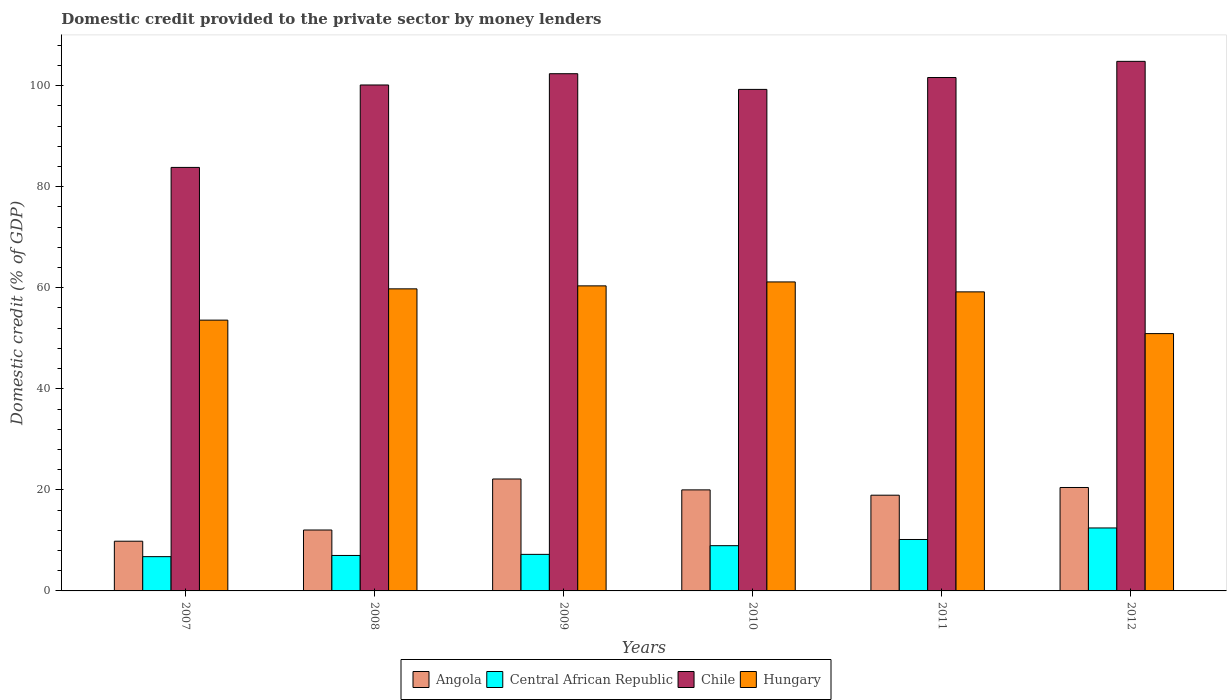How many different coloured bars are there?
Offer a very short reply. 4. How many bars are there on the 2nd tick from the right?
Provide a short and direct response. 4. What is the label of the 3rd group of bars from the left?
Your response must be concise. 2009. In how many cases, is the number of bars for a given year not equal to the number of legend labels?
Make the answer very short. 0. What is the domestic credit provided to the private sector by money lenders in Central African Republic in 2012?
Provide a short and direct response. 12.46. Across all years, what is the maximum domestic credit provided to the private sector by money lenders in Central African Republic?
Offer a terse response. 12.46. Across all years, what is the minimum domestic credit provided to the private sector by money lenders in Hungary?
Make the answer very short. 50.93. In which year was the domestic credit provided to the private sector by money lenders in Central African Republic maximum?
Offer a very short reply. 2012. In which year was the domestic credit provided to the private sector by money lenders in Central African Republic minimum?
Make the answer very short. 2007. What is the total domestic credit provided to the private sector by money lenders in Hungary in the graph?
Your answer should be compact. 345.05. What is the difference between the domestic credit provided to the private sector by money lenders in Central African Republic in 2008 and that in 2010?
Give a very brief answer. -1.94. What is the difference between the domestic credit provided to the private sector by money lenders in Central African Republic in 2008 and the domestic credit provided to the private sector by money lenders in Angola in 2011?
Keep it short and to the point. -11.93. What is the average domestic credit provided to the private sector by money lenders in Chile per year?
Provide a short and direct response. 98.67. In the year 2012, what is the difference between the domestic credit provided to the private sector by money lenders in Chile and domestic credit provided to the private sector by money lenders in Hungary?
Offer a terse response. 53.89. In how many years, is the domestic credit provided to the private sector by money lenders in Hungary greater than 80 %?
Provide a succinct answer. 0. What is the ratio of the domestic credit provided to the private sector by money lenders in Angola in 2010 to that in 2012?
Keep it short and to the point. 0.98. What is the difference between the highest and the second highest domestic credit provided to the private sector by money lenders in Hungary?
Provide a succinct answer. 0.78. What is the difference between the highest and the lowest domestic credit provided to the private sector by money lenders in Hungary?
Give a very brief answer. 10.23. Is the sum of the domestic credit provided to the private sector by money lenders in Hungary in 2009 and 2012 greater than the maximum domestic credit provided to the private sector by money lenders in Chile across all years?
Offer a very short reply. Yes. Is it the case that in every year, the sum of the domestic credit provided to the private sector by money lenders in Angola and domestic credit provided to the private sector by money lenders in Chile is greater than the sum of domestic credit provided to the private sector by money lenders in Hungary and domestic credit provided to the private sector by money lenders in Central African Republic?
Your answer should be very brief. No. What does the 1st bar from the right in 2012 represents?
Offer a very short reply. Hungary. Is it the case that in every year, the sum of the domestic credit provided to the private sector by money lenders in Angola and domestic credit provided to the private sector by money lenders in Hungary is greater than the domestic credit provided to the private sector by money lenders in Central African Republic?
Keep it short and to the point. Yes. What is the difference between two consecutive major ticks on the Y-axis?
Provide a succinct answer. 20. Does the graph contain grids?
Offer a very short reply. No. Where does the legend appear in the graph?
Offer a very short reply. Bottom center. How many legend labels are there?
Ensure brevity in your answer.  4. How are the legend labels stacked?
Keep it short and to the point. Horizontal. What is the title of the graph?
Make the answer very short. Domestic credit provided to the private sector by money lenders. What is the label or title of the Y-axis?
Make the answer very short. Domestic credit (% of GDP). What is the Domestic credit (% of GDP) in Angola in 2007?
Provide a succinct answer. 9.84. What is the Domestic credit (% of GDP) of Central African Republic in 2007?
Provide a succinct answer. 6.78. What is the Domestic credit (% of GDP) in Chile in 2007?
Keep it short and to the point. 83.82. What is the Domestic credit (% of GDP) of Hungary in 2007?
Your answer should be compact. 53.6. What is the Domestic credit (% of GDP) of Angola in 2008?
Your answer should be compact. 12.06. What is the Domestic credit (% of GDP) in Central African Republic in 2008?
Ensure brevity in your answer.  7.02. What is the Domestic credit (% of GDP) of Chile in 2008?
Offer a terse response. 100.14. What is the Domestic credit (% of GDP) in Hungary in 2008?
Your answer should be very brief. 59.79. What is the Domestic credit (% of GDP) in Angola in 2009?
Provide a short and direct response. 22.15. What is the Domestic credit (% of GDP) of Central African Republic in 2009?
Your answer should be very brief. 7.23. What is the Domestic credit (% of GDP) of Chile in 2009?
Offer a very short reply. 102.37. What is the Domestic credit (% of GDP) of Hungary in 2009?
Your answer should be compact. 60.38. What is the Domestic credit (% of GDP) of Angola in 2010?
Provide a short and direct response. 20. What is the Domestic credit (% of GDP) in Central African Republic in 2010?
Your answer should be compact. 8.96. What is the Domestic credit (% of GDP) of Chile in 2010?
Ensure brevity in your answer.  99.27. What is the Domestic credit (% of GDP) of Hungary in 2010?
Your answer should be compact. 61.16. What is the Domestic credit (% of GDP) in Angola in 2011?
Make the answer very short. 18.95. What is the Domestic credit (% of GDP) in Central African Republic in 2011?
Offer a very short reply. 10.18. What is the Domestic credit (% of GDP) in Chile in 2011?
Your answer should be compact. 101.62. What is the Domestic credit (% of GDP) in Hungary in 2011?
Keep it short and to the point. 59.19. What is the Domestic credit (% of GDP) in Angola in 2012?
Make the answer very short. 20.47. What is the Domestic credit (% of GDP) in Central African Republic in 2012?
Make the answer very short. 12.46. What is the Domestic credit (% of GDP) in Chile in 2012?
Ensure brevity in your answer.  104.82. What is the Domestic credit (% of GDP) of Hungary in 2012?
Keep it short and to the point. 50.93. Across all years, what is the maximum Domestic credit (% of GDP) of Angola?
Offer a terse response. 22.15. Across all years, what is the maximum Domestic credit (% of GDP) in Central African Republic?
Ensure brevity in your answer.  12.46. Across all years, what is the maximum Domestic credit (% of GDP) in Chile?
Keep it short and to the point. 104.82. Across all years, what is the maximum Domestic credit (% of GDP) of Hungary?
Ensure brevity in your answer.  61.16. Across all years, what is the minimum Domestic credit (% of GDP) of Angola?
Give a very brief answer. 9.84. Across all years, what is the minimum Domestic credit (% of GDP) in Central African Republic?
Offer a terse response. 6.78. Across all years, what is the minimum Domestic credit (% of GDP) of Chile?
Your answer should be very brief. 83.82. Across all years, what is the minimum Domestic credit (% of GDP) in Hungary?
Provide a succinct answer. 50.93. What is the total Domestic credit (% of GDP) in Angola in the graph?
Your answer should be very brief. 103.47. What is the total Domestic credit (% of GDP) of Central African Republic in the graph?
Offer a terse response. 52.64. What is the total Domestic credit (% of GDP) in Chile in the graph?
Offer a very short reply. 592.04. What is the total Domestic credit (% of GDP) in Hungary in the graph?
Ensure brevity in your answer.  345.05. What is the difference between the Domestic credit (% of GDP) in Angola in 2007 and that in 2008?
Keep it short and to the point. -2.22. What is the difference between the Domestic credit (% of GDP) in Central African Republic in 2007 and that in 2008?
Offer a very short reply. -0.24. What is the difference between the Domestic credit (% of GDP) in Chile in 2007 and that in 2008?
Your response must be concise. -16.32. What is the difference between the Domestic credit (% of GDP) of Hungary in 2007 and that in 2008?
Provide a succinct answer. -6.19. What is the difference between the Domestic credit (% of GDP) in Angola in 2007 and that in 2009?
Your answer should be very brief. -12.32. What is the difference between the Domestic credit (% of GDP) in Central African Republic in 2007 and that in 2009?
Give a very brief answer. -0.45. What is the difference between the Domestic credit (% of GDP) in Chile in 2007 and that in 2009?
Your answer should be compact. -18.55. What is the difference between the Domestic credit (% of GDP) of Hungary in 2007 and that in 2009?
Offer a very short reply. -6.78. What is the difference between the Domestic credit (% of GDP) in Angola in 2007 and that in 2010?
Your answer should be very brief. -10.16. What is the difference between the Domestic credit (% of GDP) in Central African Republic in 2007 and that in 2010?
Your response must be concise. -2.17. What is the difference between the Domestic credit (% of GDP) in Chile in 2007 and that in 2010?
Offer a very short reply. -15.44. What is the difference between the Domestic credit (% of GDP) of Hungary in 2007 and that in 2010?
Your response must be concise. -7.56. What is the difference between the Domestic credit (% of GDP) in Angola in 2007 and that in 2011?
Ensure brevity in your answer.  -9.11. What is the difference between the Domestic credit (% of GDP) of Central African Republic in 2007 and that in 2011?
Make the answer very short. -3.4. What is the difference between the Domestic credit (% of GDP) of Chile in 2007 and that in 2011?
Provide a short and direct response. -17.79. What is the difference between the Domestic credit (% of GDP) in Hungary in 2007 and that in 2011?
Your answer should be compact. -5.59. What is the difference between the Domestic credit (% of GDP) in Angola in 2007 and that in 2012?
Provide a succinct answer. -10.63. What is the difference between the Domestic credit (% of GDP) of Central African Republic in 2007 and that in 2012?
Your answer should be compact. -5.68. What is the difference between the Domestic credit (% of GDP) of Chile in 2007 and that in 2012?
Your response must be concise. -20.99. What is the difference between the Domestic credit (% of GDP) in Hungary in 2007 and that in 2012?
Provide a succinct answer. 2.67. What is the difference between the Domestic credit (% of GDP) of Angola in 2008 and that in 2009?
Your answer should be very brief. -10.1. What is the difference between the Domestic credit (% of GDP) of Central African Republic in 2008 and that in 2009?
Offer a terse response. -0.21. What is the difference between the Domestic credit (% of GDP) in Chile in 2008 and that in 2009?
Offer a very short reply. -2.23. What is the difference between the Domestic credit (% of GDP) of Hungary in 2008 and that in 2009?
Make the answer very short. -0.59. What is the difference between the Domestic credit (% of GDP) in Angola in 2008 and that in 2010?
Your answer should be compact. -7.94. What is the difference between the Domestic credit (% of GDP) in Central African Republic in 2008 and that in 2010?
Your answer should be very brief. -1.94. What is the difference between the Domestic credit (% of GDP) in Chile in 2008 and that in 2010?
Provide a short and direct response. 0.87. What is the difference between the Domestic credit (% of GDP) of Hungary in 2008 and that in 2010?
Your answer should be very brief. -1.37. What is the difference between the Domestic credit (% of GDP) in Angola in 2008 and that in 2011?
Make the answer very short. -6.89. What is the difference between the Domestic credit (% of GDP) of Central African Republic in 2008 and that in 2011?
Make the answer very short. -3.16. What is the difference between the Domestic credit (% of GDP) in Chile in 2008 and that in 2011?
Keep it short and to the point. -1.48. What is the difference between the Domestic credit (% of GDP) of Hungary in 2008 and that in 2011?
Provide a short and direct response. 0.6. What is the difference between the Domestic credit (% of GDP) of Angola in 2008 and that in 2012?
Ensure brevity in your answer.  -8.41. What is the difference between the Domestic credit (% of GDP) in Central African Republic in 2008 and that in 2012?
Provide a succinct answer. -5.44. What is the difference between the Domestic credit (% of GDP) in Chile in 2008 and that in 2012?
Your response must be concise. -4.68. What is the difference between the Domestic credit (% of GDP) of Hungary in 2008 and that in 2012?
Make the answer very short. 8.86. What is the difference between the Domestic credit (% of GDP) of Angola in 2009 and that in 2010?
Provide a short and direct response. 2.16. What is the difference between the Domestic credit (% of GDP) of Central African Republic in 2009 and that in 2010?
Offer a terse response. -1.72. What is the difference between the Domestic credit (% of GDP) in Chile in 2009 and that in 2010?
Offer a terse response. 3.11. What is the difference between the Domestic credit (% of GDP) of Hungary in 2009 and that in 2010?
Keep it short and to the point. -0.78. What is the difference between the Domestic credit (% of GDP) in Angola in 2009 and that in 2011?
Make the answer very short. 3.21. What is the difference between the Domestic credit (% of GDP) of Central African Republic in 2009 and that in 2011?
Keep it short and to the point. -2.95. What is the difference between the Domestic credit (% of GDP) of Chile in 2009 and that in 2011?
Your response must be concise. 0.76. What is the difference between the Domestic credit (% of GDP) in Hungary in 2009 and that in 2011?
Your answer should be compact. 1.19. What is the difference between the Domestic credit (% of GDP) in Angola in 2009 and that in 2012?
Provide a short and direct response. 1.68. What is the difference between the Domestic credit (% of GDP) in Central African Republic in 2009 and that in 2012?
Your answer should be very brief. -5.23. What is the difference between the Domestic credit (% of GDP) in Chile in 2009 and that in 2012?
Your answer should be compact. -2.44. What is the difference between the Domestic credit (% of GDP) of Hungary in 2009 and that in 2012?
Offer a terse response. 9.45. What is the difference between the Domestic credit (% of GDP) of Angola in 2010 and that in 2011?
Provide a succinct answer. 1.05. What is the difference between the Domestic credit (% of GDP) of Central African Republic in 2010 and that in 2011?
Your answer should be very brief. -1.23. What is the difference between the Domestic credit (% of GDP) of Chile in 2010 and that in 2011?
Offer a very short reply. -2.35. What is the difference between the Domestic credit (% of GDP) of Hungary in 2010 and that in 2011?
Provide a short and direct response. 1.97. What is the difference between the Domestic credit (% of GDP) of Angola in 2010 and that in 2012?
Keep it short and to the point. -0.47. What is the difference between the Domestic credit (% of GDP) of Central African Republic in 2010 and that in 2012?
Offer a very short reply. -3.51. What is the difference between the Domestic credit (% of GDP) of Chile in 2010 and that in 2012?
Your answer should be compact. -5.55. What is the difference between the Domestic credit (% of GDP) of Hungary in 2010 and that in 2012?
Give a very brief answer. 10.23. What is the difference between the Domestic credit (% of GDP) of Angola in 2011 and that in 2012?
Ensure brevity in your answer.  -1.52. What is the difference between the Domestic credit (% of GDP) in Central African Republic in 2011 and that in 2012?
Keep it short and to the point. -2.28. What is the difference between the Domestic credit (% of GDP) in Chile in 2011 and that in 2012?
Provide a succinct answer. -3.2. What is the difference between the Domestic credit (% of GDP) in Hungary in 2011 and that in 2012?
Offer a terse response. 8.26. What is the difference between the Domestic credit (% of GDP) in Angola in 2007 and the Domestic credit (% of GDP) in Central African Republic in 2008?
Offer a terse response. 2.82. What is the difference between the Domestic credit (% of GDP) in Angola in 2007 and the Domestic credit (% of GDP) in Chile in 2008?
Give a very brief answer. -90.3. What is the difference between the Domestic credit (% of GDP) of Angola in 2007 and the Domestic credit (% of GDP) of Hungary in 2008?
Offer a terse response. -49.95. What is the difference between the Domestic credit (% of GDP) of Central African Republic in 2007 and the Domestic credit (% of GDP) of Chile in 2008?
Provide a short and direct response. -93.36. What is the difference between the Domestic credit (% of GDP) in Central African Republic in 2007 and the Domestic credit (% of GDP) in Hungary in 2008?
Provide a succinct answer. -53.01. What is the difference between the Domestic credit (% of GDP) in Chile in 2007 and the Domestic credit (% of GDP) in Hungary in 2008?
Offer a very short reply. 24.04. What is the difference between the Domestic credit (% of GDP) of Angola in 2007 and the Domestic credit (% of GDP) of Central African Republic in 2009?
Your response must be concise. 2.6. What is the difference between the Domestic credit (% of GDP) of Angola in 2007 and the Domestic credit (% of GDP) of Chile in 2009?
Provide a short and direct response. -92.53. What is the difference between the Domestic credit (% of GDP) of Angola in 2007 and the Domestic credit (% of GDP) of Hungary in 2009?
Provide a short and direct response. -50.54. What is the difference between the Domestic credit (% of GDP) in Central African Republic in 2007 and the Domestic credit (% of GDP) in Chile in 2009?
Keep it short and to the point. -95.59. What is the difference between the Domestic credit (% of GDP) of Central African Republic in 2007 and the Domestic credit (% of GDP) of Hungary in 2009?
Provide a short and direct response. -53.6. What is the difference between the Domestic credit (% of GDP) of Chile in 2007 and the Domestic credit (% of GDP) of Hungary in 2009?
Keep it short and to the point. 23.45. What is the difference between the Domestic credit (% of GDP) in Angola in 2007 and the Domestic credit (% of GDP) in Central African Republic in 2010?
Provide a succinct answer. 0.88. What is the difference between the Domestic credit (% of GDP) of Angola in 2007 and the Domestic credit (% of GDP) of Chile in 2010?
Provide a short and direct response. -89.43. What is the difference between the Domestic credit (% of GDP) in Angola in 2007 and the Domestic credit (% of GDP) in Hungary in 2010?
Provide a short and direct response. -51.32. What is the difference between the Domestic credit (% of GDP) of Central African Republic in 2007 and the Domestic credit (% of GDP) of Chile in 2010?
Keep it short and to the point. -92.48. What is the difference between the Domestic credit (% of GDP) in Central African Republic in 2007 and the Domestic credit (% of GDP) in Hungary in 2010?
Offer a terse response. -54.38. What is the difference between the Domestic credit (% of GDP) of Chile in 2007 and the Domestic credit (% of GDP) of Hungary in 2010?
Your response must be concise. 22.67. What is the difference between the Domestic credit (% of GDP) in Angola in 2007 and the Domestic credit (% of GDP) in Central African Republic in 2011?
Your answer should be very brief. -0.34. What is the difference between the Domestic credit (% of GDP) in Angola in 2007 and the Domestic credit (% of GDP) in Chile in 2011?
Offer a very short reply. -91.78. What is the difference between the Domestic credit (% of GDP) in Angola in 2007 and the Domestic credit (% of GDP) in Hungary in 2011?
Give a very brief answer. -49.35. What is the difference between the Domestic credit (% of GDP) of Central African Republic in 2007 and the Domestic credit (% of GDP) of Chile in 2011?
Provide a succinct answer. -94.83. What is the difference between the Domestic credit (% of GDP) in Central African Republic in 2007 and the Domestic credit (% of GDP) in Hungary in 2011?
Offer a terse response. -52.41. What is the difference between the Domestic credit (% of GDP) of Chile in 2007 and the Domestic credit (% of GDP) of Hungary in 2011?
Your answer should be very brief. 24.63. What is the difference between the Domestic credit (% of GDP) in Angola in 2007 and the Domestic credit (% of GDP) in Central African Republic in 2012?
Offer a terse response. -2.62. What is the difference between the Domestic credit (% of GDP) of Angola in 2007 and the Domestic credit (% of GDP) of Chile in 2012?
Your response must be concise. -94.98. What is the difference between the Domestic credit (% of GDP) in Angola in 2007 and the Domestic credit (% of GDP) in Hungary in 2012?
Give a very brief answer. -41.09. What is the difference between the Domestic credit (% of GDP) in Central African Republic in 2007 and the Domestic credit (% of GDP) in Chile in 2012?
Make the answer very short. -98.03. What is the difference between the Domestic credit (% of GDP) of Central African Republic in 2007 and the Domestic credit (% of GDP) of Hungary in 2012?
Make the answer very short. -44.15. What is the difference between the Domestic credit (% of GDP) of Chile in 2007 and the Domestic credit (% of GDP) of Hungary in 2012?
Your response must be concise. 32.9. What is the difference between the Domestic credit (% of GDP) in Angola in 2008 and the Domestic credit (% of GDP) in Central African Republic in 2009?
Your answer should be very brief. 4.82. What is the difference between the Domestic credit (% of GDP) in Angola in 2008 and the Domestic credit (% of GDP) in Chile in 2009?
Give a very brief answer. -90.31. What is the difference between the Domestic credit (% of GDP) of Angola in 2008 and the Domestic credit (% of GDP) of Hungary in 2009?
Offer a very short reply. -48.32. What is the difference between the Domestic credit (% of GDP) of Central African Republic in 2008 and the Domestic credit (% of GDP) of Chile in 2009?
Your response must be concise. -95.35. What is the difference between the Domestic credit (% of GDP) of Central African Republic in 2008 and the Domestic credit (% of GDP) of Hungary in 2009?
Your answer should be very brief. -53.36. What is the difference between the Domestic credit (% of GDP) of Chile in 2008 and the Domestic credit (% of GDP) of Hungary in 2009?
Give a very brief answer. 39.76. What is the difference between the Domestic credit (% of GDP) in Angola in 2008 and the Domestic credit (% of GDP) in Central African Republic in 2010?
Your response must be concise. 3.1. What is the difference between the Domestic credit (% of GDP) of Angola in 2008 and the Domestic credit (% of GDP) of Chile in 2010?
Your answer should be compact. -87.21. What is the difference between the Domestic credit (% of GDP) in Angola in 2008 and the Domestic credit (% of GDP) in Hungary in 2010?
Your answer should be compact. -49.1. What is the difference between the Domestic credit (% of GDP) in Central African Republic in 2008 and the Domestic credit (% of GDP) in Chile in 2010?
Your answer should be compact. -92.25. What is the difference between the Domestic credit (% of GDP) of Central African Republic in 2008 and the Domestic credit (% of GDP) of Hungary in 2010?
Provide a short and direct response. -54.14. What is the difference between the Domestic credit (% of GDP) in Chile in 2008 and the Domestic credit (% of GDP) in Hungary in 2010?
Your answer should be compact. 38.98. What is the difference between the Domestic credit (% of GDP) in Angola in 2008 and the Domestic credit (% of GDP) in Central African Republic in 2011?
Provide a succinct answer. 1.88. What is the difference between the Domestic credit (% of GDP) of Angola in 2008 and the Domestic credit (% of GDP) of Chile in 2011?
Keep it short and to the point. -89.56. What is the difference between the Domestic credit (% of GDP) in Angola in 2008 and the Domestic credit (% of GDP) in Hungary in 2011?
Your answer should be very brief. -47.13. What is the difference between the Domestic credit (% of GDP) in Central African Republic in 2008 and the Domestic credit (% of GDP) in Chile in 2011?
Provide a succinct answer. -94.6. What is the difference between the Domestic credit (% of GDP) in Central African Republic in 2008 and the Domestic credit (% of GDP) in Hungary in 2011?
Keep it short and to the point. -52.17. What is the difference between the Domestic credit (% of GDP) in Chile in 2008 and the Domestic credit (% of GDP) in Hungary in 2011?
Provide a succinct answer. 40.95. What is the difference between the Domestic credit (% of GDP) of Angola in 2008 and the Domestic credit (% of GDP) of Central African Republic in 2012?
Ensure brevity in your answer.  -0.4. What is the difference between the Domestic credit (% of GDP) of Angola in 2008 and the Domestic credit (% of GDP) of Chile in 2012?
Your answer should be very brief. -92.76. What is the difference between the Domestic credit (% of GDP) in Angola in 2008 and the Domestic credit (% of GDP) in Hungary in 2012?
Ensure brevity in your answer.  -38.87. What is the difference between the Domestic credit (% of GDP) of Central African Republic in 2008 and the Domestic credit (% of GDP) of Chile in 2012?
Your response must be concise. -97.8. What is the difference between the Domestic credit (% of GDP) in Central African Republic in 2008 and the Domestic credit (% of GDP) in Hungary in 2012?
Offer a very short reply. -43.91. What is the difference between the Domestic credit (% of GDP) of Chile in 2008 and the Domestic credit (% of GDP) of Hungary in 2012?
Ensure brevity in your answer.  49.21. What is the difference between the Domestic credit (% of GDP) in Angola in 2009 and the Domestic credit (% of GDP) in Central African Republic in 2010?
Offer a very short reply. 13.2. What is the difference between the Domestic credit (% of GDP) of Angola in 2009 and the Domestic credit (% of GDP) of Chile in 2010?
Provide a succinct answer. -77.11. What is the difference between the Domestic credit (% of GDP) of Angola in 2009 and the Domestic credit (% of GDP) of Hungary in 2010?
Offer a terse response. -39.01. What is the difference between the Domestic credit (% of GDP) in Central African Republic in 2009 and the Domestic credit (% of GDP) in Chile in 2010?
Make the answer very short. -92.03. What is the difference between the Domestic credit (% of GDP) of Central African Republic in 2009 and the Domestic credit (% of GDP) of Hungary in 2010?
Offer a terse response. -53.92. What is the difference between the Domestic credit (% of GDP) in Chile in 2009 and the Domestic credit (% of GDP) in Hungary in 2010?
Your answer should be compact. 41.21. What is the difference between the Domestic credit (% of GDP) of Angola in 2009 and the Domestic credit (% of GDP) of Central African Republic in 2011?
Ensure brevity in your answer.  11.97. What is the difference between the Domestic credit (% of GDP) of Angola in 2009 and the Domestic credit (% of GDP) of Chile in 2011?
Your answer should be very brief. -79.46. What is the difference between the Domestic credit (% of GDP) of Angola in 2009 and the Domestic credit (% of GDP) of Hungary in 2011?
Your answer should be very brief. -37.04. What is the difference between the Domestic credit (% of GDP) in Central African Republic in 2009 and the Domestic credit (% of GDP) in Chile in 2011?
Ensure brevity in your answer.  -94.38. What is the difference between the Domestic credit (% of GDP) of Central African Republic in 2009 and the Domestic credit (% of GDP) of Hungary in 2011?
Give a very brief answer. -51.96. What is the difference between the Domestic credit (% of GDP) of Chile in 2009 and the Domestic credit (% of GDP) of Hungary in 2011?
Make the answer very short. 43.18. What is the difference between the Domestic credit (% of GDP) in Angola in 2009 and the Domestic credit (% of GDP) in Central African Republic in 2012?
Give a very brief answer. 9.69. What is the difference between the Domestic credit (% of GDP) in Angola in 2009 and the Domestic credit (% of GDP) in Chile in 2012?
Keep it short and to the point. -82.66. What is the difference between the Domestic credit (% of GDP) of Angola in 2009 and the Domestic credit (% of GDP) of Hungary in 2012?
Your response must be concise. -28.78. What is the difference between the Domestic credit (% of GDP) of Central African Republic in 2009 and the Domestic credit (% of GDP) of Chile in 2012?
Make the answer very short. -97.58. What is the difference between the Domestic credit (% of GDP) in Central African Republic in 2009 and the Domestic credit (% of GDP) in Hungary in 2012?
Provide a short and direct response. -43.7. What is the difference between the Domestic credit (% of GDP) of Chile in 2009 and the Domestic credit (% of GDP) of Hungary in 2012?
Your answer should be very brief. 51.44. What is the difference between the Domestic credit (% of GDP) of Angola in 2010 and the Domestic credit (% of GDP) of Central African Republic in 2011?
Your answer should be compact. 9.82. What is the difference between the Domestic credit (% of GDP) of Angola in 2010 and the Domestic credit (% of GDP) of Chile in 2011?
Give a very brief answer. -81.62. What is the difference between the Domestic credit (% of GDP) of Angola in 2010 and the Domestic credit (% of GDP) of Hungary in 2011?
Ensure brevity in your answer.  -39.19. What is the difference between the Domestic credit (% of GDP) of Central African Republic in 2010 and the Domestic credit (% of GDP) of Chile in 2011?
Ensure brevity in your answer.  -92.66. What is the difference between the Domestic credit (% of GDP) in Central African Republic in 2010 and the Domestic credit (% of GDP) in Hungary in 2011?
Your response must be concise. -50.24. What is the difference between the Domestic credit (% of GDP) of Chile in 2010 and the Domestic credit (% of GDP) of Hungary in 2011?
Make the answer very short. 40.07. What is the difference between the Domestic credit (% of GDP) of Angola in 2010 and the Domestic credit (% of GDP) of Central African Republic in 2012?
Provide a succinct answer. 7.54. What is the difference between the Domestic credit (% of GDP) of Angola in 2010 and the Domestic credit (% of GDP) of Chile in 2012?
Your answer should be compact. -84.82. What is the difference between the Domestic credit (% of GDP) of Angola in 2010 and the Domestic credit (% of GDP) of Hungary in 2012?
Provide a succinct answer. -30.93. What is the difference between the Domestic credit (% of GDP) of Central African Republic in 2010 and the Domestic credit (% of GDP) of Chile in 2012?
Keep it short and to the point. -95.86. What is the difference between the Domestic credit (% of GDP) in Central African Republic in 2010 and the Domestic credit (% of GDP) in Hungary in 2012?
Make the answer very short. -41.97. What is the difference between the Domestic credit (% of GDP) in Chile in 2010 and the Domestic credit (% of GDP) in Hungary in 2012?
Your answer should be very brief. 48.34. What is the difference between the Domestic credit (% of GDP) in Angola in 2011 and the Domestic credit (% of GDP) in Central African Republic in 2012?
Offer a terse response. 6.48. What is the difference between the Domestic credit (% of GDP) of Angola in 2011 and the Domestic credit (% of GDP) of Chile in 2012?
Offer a very short reply. -85.87. What is the difference between the Domestic credit (% of GDP) of Angola in 2011 and the Domestic credit (% of GDP) of Hungary in 2012?
Offer a terse response. -31.98. What is the difference between the Domestic credit (% of GDP) in Central African Republic in 2011 and the Domestic credit (% of GDP) in Chile in 2012?
Your response must be concise. -94.64. What is the difference between the Domestic credit (% of GDP) of Central African Republic in 2011 and the Domestic credit (% of GDP) of Hungary in 2012?
Keep it short and to the point. -40.75. What is the difference between the Domestic credit (% of GDP) in Chile in 2011 and the Domestic credit (% of GDP) in Hungary in 2012?
Your response must be concise. 50.69. What is the average Domestic credit (% of GDP) of Angola per year?
Provide a short and direct response. 17.24. What is the average Domestic credit (% of GDP) of Central African Republic per year?
Offer a very short reply. 8.77. What is the average Domestic credit (% of GDP) of Chile per year?
Offer a very short reply. 98.67. What is the average Domestic credit (% of GDP) of Hungary per year?
Offer a terse response. 57.51. In the year 2007, what is the difference between the Domestic credit (% of GDP) in Angola and Domestic credit (% of GDP) in Central African Republic?
Your answer should be very brief. 3.05. In the year 2007, what is the difference between the Domestic credit (% of GDP) of Angola and Domestic credit (% of GDP) of Chile?
Provide a short and direct response. -73.99. In the year 2007, what is the difference between the Domestic credit (% of GDP) of Angola and Domestic credit (% of GDP) of Hungary?
Your answer should be compact. -43.76. In the year 2007, what is the difference between the Domestic credit (% of GDP) in Central African Republic and Domestic credit (% of GDP) in Chile?
Offer a very short reply. -77.04. In the year 2007, what is the difference between the Domestic credit (% of GDP) of Central African Republic and Domestic credit (% of GDP) of Hungary?
Offer a very short reply. -46.81. In the year 2007, what is the difference between the Domestic credit (% of GDP) of Chile and Domestic credit (% of GDP) of Hungary?
Provide a succinct answer. 30.23. In the year 2008, what is the difference between the Domestic credit (% of GDP) of Angola and Domestic credit (% of GDP) of Central African Republic?
Your response must be concise. 5.04. In the year 2008, what is the difference between the Domestic credit (% of GDP) of Angola and Domestic credit (% of GDP) of Chile?
Offer a terse response. -88.08. In the year 2008, what is the difference between the Domestic credit (% of GDP) of Angola and Domestic credit (% of GDP) of Hungary?
Your answer should be compact. -47.73. In the year 2008, what is the difference between the Domestic credit (% of GDP) in Central African Republic and Domestic credit (% of GDP) in Chile?
Keep it short and to the point. -93.12. In the year 2008, what is the difference between the Domestic credit (% of GDP) in Central African Republic and Domestic credit (% of GDP) in Hungary?
Offer a very short reply. -52.77. In the year 2008, what is the difference between the Domestic credit (% of GDP) of Chile and Domestic credit (% of GDP) of Hungary?
Keep it short and to the point. 40.35. In the year 2009, what is the difference between the Domestic credit (% of GDP) of Angola and Domestic credit (% of GDP) of Central African Republic?
Provide a short and direct response. 14.92. In the year 2009, what is the difference between the Domestic credit (% of GDP) of Angola and Domestic credit (% of GDP) of Chile?
Your answer should be very brief. -80.22. In the year 2009, what is the difference between the Domestic credit (% of GDP) in Angola and Domestic credit (% of GDP) in Hungary?
Offer a terse response. -38.23. In the year 2009, what is the difference between the Domestic credit (% of GDP) in Central African Republic and Domestic credit (% of GDP) in Chile?
Your answer should be very brief. -95.14. In the year 2009, what is the difference between the Domestic credit (% of GDP) of Central African Republic and Domestic credit (% of GDP) of Hungary?
Your answer should be very brief. -53.15. In the year 2009, what is the difference between the Domestic credit (% of GDP) of Chile and Domestic credit (% of GDP) of Hungary?
Offer a terse response. 41.99. In the year 2010, what is the difference between the Domestic credit (% of GDP) in Angola and Domestic credit (% of GDP) in Central African Republic?
Provide a short and direct response. 11.04. In the year 2010, what is the difference between the Domestic credit (% of GDP) in Angola and Domestic credit (% of GDP) in Chile?
Ensure brevity in your answer.  -79.27. In the year 2010, what is the difference between the Domestic credit (% of GDP) in Angola and Domestic credit (% of GDP) in Hungary?
Provide a short and direct response. -41.16. In the year 2010, what is the difference between the Domestic credit (% of GDP) of Central African Republic and Domestic credit (% of GDP) of Chile?
Your response must be concise. -90.31. In the year 2010, what is the difference between the Domestic credit (% of GDP) of Central African Republic and Domestic credit (% of GDP) of Hungary?
Make the answer very short. -52.2. In the year 2010, what is the difference between the Domestic credit (% of GDP) in Chile and Domestic credit (% of GDP) in Hungary?
Provide a short and direct response. 38.11. In the year 2011, what is the difference between the Domestic credit (% of GDP) of Angola and Domestic credit (% of GDP) of Central African Republic?
Ensure brevity in your answer.  8.77. In the year 2011, what is the difference between the Domestic credit (% of GDP) in Angola and Domestic credit (% of GDP) in Chile?
Offer a very short reply. -82.67. In the year 2011, what is the difference between the Domestic credit (% of GDP) in Angola and Domestic credit (% of GDP) in Hungary?
Give a very brief answer. -40.24. In the year 2011, what is the difference between the Domestic credit (% of GDP) in Central African Republic and Domestic credit (% of GDP) in Chile?
Ensure brevity in your answer.  -91.44. In the year 2011, what is the difference between the Domestic credit (% of GDP) in Central African Republic and Domestic credit (% of GDP) in Hungary?
Make the answer very short. -49.01. In the year 2011, what is the difference between the Domestic credit (% of GDP) of Chile and Domestic credit (% of GDP) of Hungary?
Offer a terse response. 42.43. In the year 2012, what is the difference between the Domestic credit (% of GDP) of Angola and Domestic credit (% of GDP) of Central African Republic?
Your answer should be very brief. 8.01. In the year 2012, what is the difference between the Domestic credit (% of GDP) in Angola and Domestic credit (% of GDP) in Chile?
Your answer should be very brief. -84.35. In the year 2012, what is the difference between the Domestic credit (% of GDP) in Angola and Domestic credit (% of GDP) in Hungary?
Give a very brief answer. -30.46. In the year 2012, what is the difference between the Domestic credit (% of GDP) of Central African Republic and Domestic credit (% of GDP) of Chile?
Give a very brief answer. -92.35. In the year 2012, what is the difference between the Domestic credit (% of GDP) in Central African Republic and Domestic credit (% of GDP) in Hungary?
Offer a very short reply. -38.47. In the year 2012, what is the difference between the Domestic credit (% of GDP) in Chile and Domestic credit (% of GDP) in Hungary?
Offer a very short reply. 53.89. What is the ratio of the Domestic credit (% of GDP) in Angola in 2007 to that in 2008?
Your response must be concise. 0.82. What is the ratio of the Domestic credit (% of GDP) of Central African Republic in 2007 to that in 2008?
Your answer should be very brief. 0.97. What is the ratio of the Domestic credit (% of GDP) in Chile in 2007 to that in 2008?
Give a very brief answer. 0.84. What is the ratio of the Domestic credit (% of GDP) in Hungary in 2007 to that in 2008?
Your answer should be compact. 0.9. What is the ratio of the Domestic credit (% of GDP) of Angola in 2007 to that in 2009?
Provide a succinct answer. 0.44. What is the ratio of the Domestic credit (% of GDP) of Central African Republic in 2007 to that in 2009?
Provide a succinct answer. 0.94. What is the ratio of the Domestic credit (% of GDP) in Chile in 2007 to that in 2009?
Keep it short and to the point. 0.82. What is the ratio of the Domestic credit (% of GDP) of Hungary in 2007 to that in 2009?
Ensure brevity in your answer.  0.89. What is the ratio of the Domestic credit (% of GDP) of Angola in 2007 to that in 2010?
Make the answer very short. 0.49. What is the ratio of the Domestic credit (% of GDP) of Central African Republic in 2007 to that in 2010?
Provide a succinct answer. 0.76. What is the ratio of the Domestic credit (% of GDP) of Chile in 2007 to that in 2010?
Offer a terse response. 0.84. What is the ratio of the Domestic credit (% of GDP) in Hungary in 2007 to that in 2010?
Keep it short and to the point. 0.88. What is the ratio of the Domestic credit (% of GDP) of Angola in 2007 to that in 2011?
Ensure brevity in your answer.  0.52. What is the ratio of the Domestic credit (% of GDP) of Central African Republic in 2007 to that in 2011?
Keep it short and to the point. 0.67. What is the ratio of the Domestic credit (% of GDP) of Chile in 2007 to that in 2011?
Offer a very short reply. 0.82. What is the ratio of the Domestic credit (% of GDP) in Hungary in 2007 to that in 2011?
Keep it short and to the point. 0.91. What is the ratio of the Domestic credit (% of GDP) in Angola in 2007 to that in 2012?
Keep it short and to the point. 0.48. What is the ratio of the Domestic credit (% of GDP) of Central African Republic in 2007 to that in 2012?
Keep it short and to the point. 0.54. What is the ratio of the Domestic credit (% of GDP) in Chile in 2007 to that in 2012?
Provide a short and direct response. 0.8. What is the ratio of the Domestic credit (% of GDP) in Hungary in 2007 to that in 2012?
Keep it short and to the point. 1.05. What is the ratio of the Domestic credit (% of GDP) of Angola in 2008 to that in 2009?
Your response must be concise. 0.54. What is the ratio of the Domestic credit (% of GDP) of Central African Republic in 2008 to that in 2009?
Ensure brevity in your answer.  0.97. What is the ratio of the Domestic credit (% of GDP) in Chile in 2008 to that in 2009?
Keep it short and to the point. 0.98. What is the ratio of the Domestic credit (% of GDP) of Hungary in 2008 to that in 2009?
Keep it short and to the point. 0.99. What is the ratio of the Domestic credit (% of GDP) in Angola in 2008 to that in 2010?
Make the answer very short. 0.6. What is the ratio of the Domestic credit (% of GDP) of Central African Republic in 2008 to that in 2010?
Your response must be concise. 0.78. What is the ratio of the Domestic credit (% of GDP) of Chile in 2008 to that in 2010?
Ensure brevity in your answer.  1.01. What is the ratio of the Domestic credit (% of GDP) in Hungary in 2008 to that in 2010?
Your answer should be compact. 0.98. What is the ratio of the Domestic credit (% of GDP) of Angola in 2008 to that in 2011?
Provide a succinct answer. 0.64. What is the ratio of the Domestic credit (% of GDP) in Central African Republic in 2008 to that in 2011?
Give a very brief answer. 0.69. What is the ratio of the Domestic credit (% of GDP) of Chile in 2008 to that in 2011?
Offer a terse response. 0.99. What is the ratio of the Domestic credit (% of GDP) of Hungary in 2008 to that in 2011?
Keep it short and to the point. 1.01. What is the ratio of the Domestic credit (% of GDP) of Angola in 2008 to that in 2012?
Keep it short and to the point. 0.59. What is the ratio of the Domestic credit (% of GDP) of Central African Republic in 2008 to that in 2012?
Keep it short and to the point. 0.56. What is the ratio of the Domestic credit (% of GDP) in Chile in 2008 to that in 2012?
Ensure brevity in your answer.  0.96. What is the ratio of the Domestic credit (% of GDP) of Hungary in 2008 to that in 2012?
Give a very brief answer. 1.17. What is the ratio of the Domestic credit (% of GDP) in Angola in 2009 to that in 2010?
Offer a very short reply. 1.11. What is the ratio of the Domestic credit (% of GDP) in Central African Republic in 2009 to that in 2010?
Provide a short and direct response. 0.81. What is the ratio of the Domestic credit (% of GDP) in Chile in 2009 to that in 2010?
Offer a terse response. 1.03. What is the ratio of the Domestic credit (% of GDP) of Hungary in 2009 to that in 2010?
Your response must be concise. 0.99. What is the ratio of the Domestic credit (% of GDP) in Angola in 2009 to that in 2011?
Your answer should be compact. 1.17. What is the ratio of the Domestic credit (% of GDP) in Central African Republic in 2009 to that in 2011?
Ensure brevity in your answer.  0.71. What is the ratio of the Domestic credit (% of GDP) in Chile in 2009 to that in 2011?
Give a very brief answer. 1.01. What is the ratio of the Domestic credit (% of GDP) in Hungary in 2009 to that in 2011?
Ensure brevity in your answer.  1.02. What is the ratio of the Domestic credit (% of GDP) of Angola in 2009 to that in 2012?
Provide a succinct answer. 1.08. What is the ratio of the Domestic credit (% of GDP) of Central African Republic in 2009 to that in 2012?
Ensure brevity in your answer.  0.58. What is the ratio of the Domestic credit (% of GDP) in Chile in 2009 to that in 2012?
Your answer should be very brief. 0.98. What is the ratio of the Domestic credit (% of GDP) of Hungary in 2009 to that in 2012?
Ensure brevity in your answer.  1.19. What is the ratio of the Domestic credit (% of GDP) of Angola in 2010 to that in 2011?
Offer a very short reply. 1.06. What is the ratio of the Domestic credit (% of GDP) in Central African Republic in 2010 to that in 2011?
Your answer should be very brief. 0.88. What is the ratio of the Domestic credit (% of GDP) in Chile in 2010 to that in 2011?
Make the answer very short. 0.98. What is the ratio of the Domestic credit (% of GDP) of Hungary in 2010 to that in 2011?
Provide a short and direct response. 1.03. What is the ratio of the Domestic credit (% of GDP) of Angola in 2010 to that in 2012?
Make the answer very short. 0.98. What is the ratio of the Domestic credit (% of GDP) in Central African Republic in 2010 to that in 2012?
Provide a succinct answer. 0.72. What is the ratio of the Domestic credit (% of GDP) of Chile in 2010 to that in 2012?
Provide a succinct answer. 0.95. What is the ratio of the Domestic credit (% of GDP) in Hungary in 2010 to that in 2012?
Give a very brief answer. 1.2. What is the ratio of the Domestic credit (% of GDP) in Angola in 2011 to that in 2012?
Provide a succinct answer. 0.93. What is the ratio of the Domestic credit (% of GDP) of Central African Republic in 2011 to that in 2012?
Give a very brief answer. 0.82. What is the ratio of the Domestic credit (% of GDP) in Chile in 2011 to that in 2012?
Your answer should be very brief. 0.97. What is the ratio of the Domestic credit (% of GDP) of Hungary in 2011 to that in 2012?
Provide a short and direct response. 1.16. What is the difference between the highest and the second highest Domestic credit (% of GDP) in Angola?
Your response must be concise. 1.68. What is the difference between the highest and the second highest Domestic credit (% of GDP) of Central African Republic?
Provide a succinct answer. 2.28. What is the difference between the highest and the second highest Domestic credit (% of GDP) of Chile?
Provide a succinct answer. 2.44. What is the difference between the highest and the second highest Domestic credit (% of GDP) of Hungary?
Provide a short and direct response. 0.78. What is the difference between the highest and the lowest Domestic credit (% of GDP) in Angola?
Provide a short and direct response. 12.32. What is the difference between the highest and the lowest Domestic credit (% of GDP) in Central African Republic?
Your answer should be compact. 5.68. What is the difference between the highest and the lowest Domestic credit (% of GDP) of Chile?
Your answer should be very brief. 20.99. What is the difference between the highest and the lowest Domestic credit (% of GDP) in Hungary?
Your answer should be very brief. 10.23. 